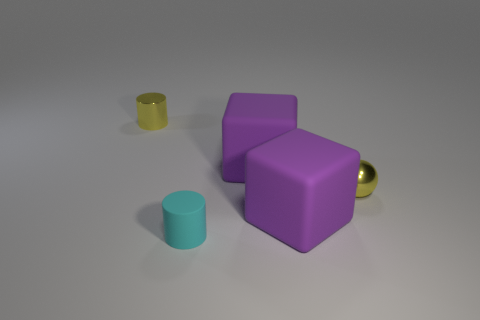Add 3 yellow things. How many objects exist? 8 Subtract all cubes. How many objects are left? 3 Add 1 rubber things. How many rubber things are left? 4 Add 5 small matte things. How many small matte things exist? 6 Subtract 0 yellow blocks. How many objects are left? 5 Subtract all big matte objects. Subtract all metallic cylinders. How many objects are left? 2 